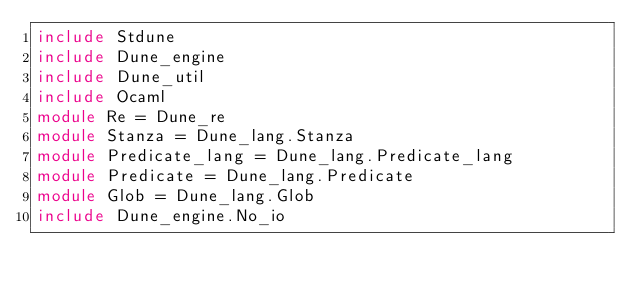Convert code to text. <code><loc_0><loc_0><loc_500><loc_500><_OCaml_>include Stdune
include Dune_engine
include Dune_util
include Ocaml
module Re = Dune_re
module Stanza = Dune_lang.Stanza
module Predicate_lang = Dune_lang.Predicate_lang
module Predicate = Dune_lang.Predicate
module Glob = Dune_lang.Glob
include Dune_engine.No_io
</code> 